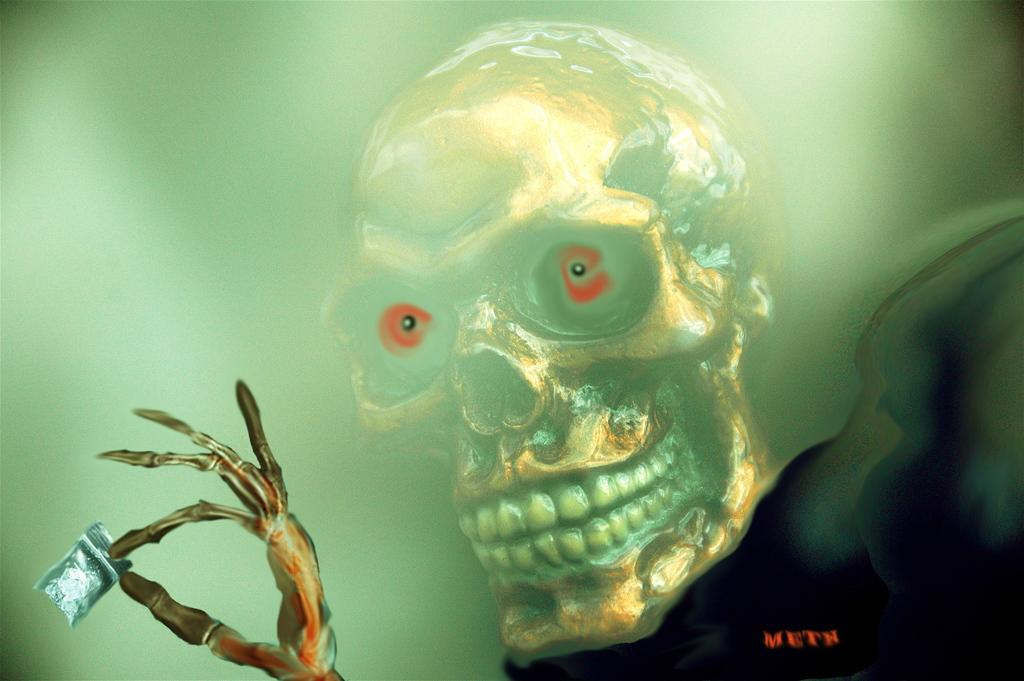What is the main subject of the image? The main subject of the image is an animated picture of a skull. How many deer are visible in the image? There are no deer present in the image; it features an animated picture of a skull. What type of surprise can be seen in the image? There is no surprise depicted in the image; it features an animated picture of a skull. 